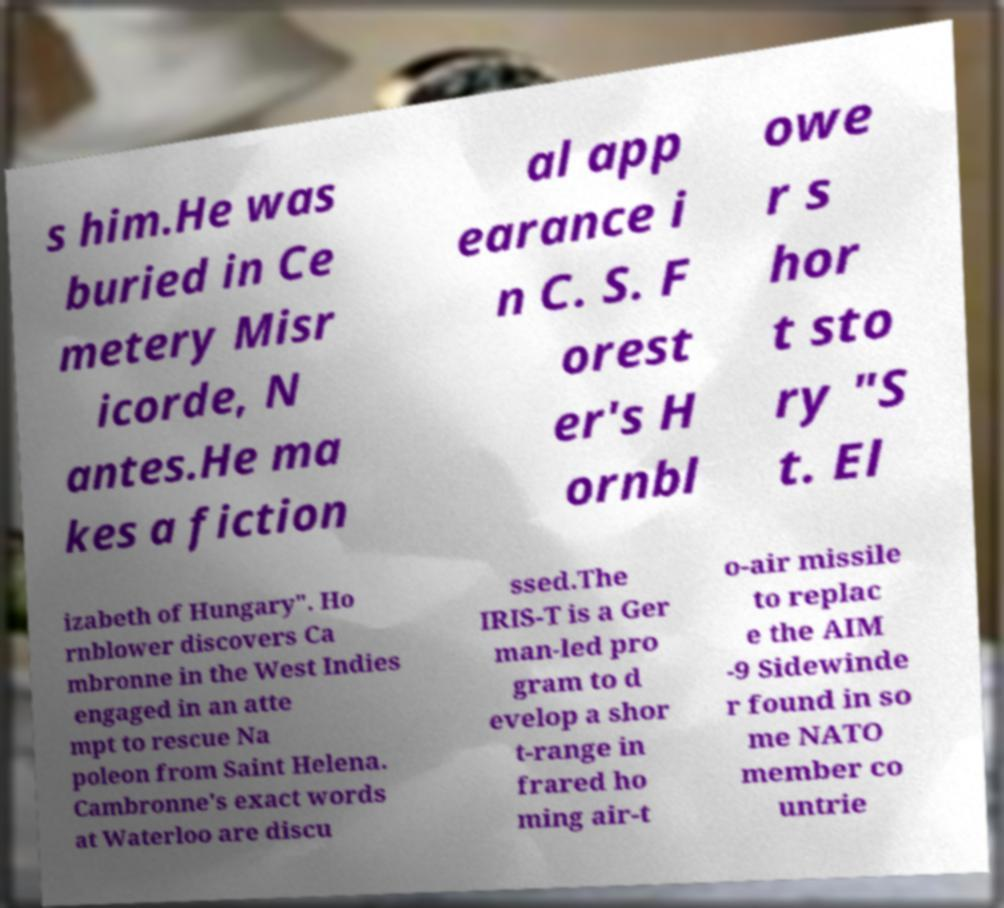Can you read and provide the text displayed in the image?This photo seems to have some interesting text. Can you extract and type it out for me? s him.He was buried in Ce metery Misr icorde, N antes.He ma kes a fiction al app earance i n C. S. F orest er's H ornbl owe r s hor t sto ry "S t. El izabeth of Hungary". Ho rnblower discovers Ca mbronne in the West Indies engaged in an atte mpt to rescue Na poleon from Saint Helena. Cambronne's exact words at Waterloo are discu ssed.The IRIS-T is a Ger man-led pro gram to d evelop a shor t-range in frared ho ming air-t o-air missile to replac e the AIM -9 Sidewinde r found in so me NATO member co untrie 